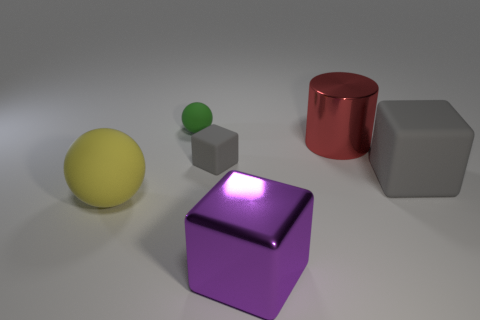Add 4 big red metallic objects. How many objects exist? 10 Subtract all balls. How many objects are left? 4 Add 2 large purple metal things. How many large purple metal things are left? 3 Add 4 large red cylinders. How many large red cylinders exist? 5 Subtract 0 gray balls. How many objects are left? 6 Subtract all large shiny cubes. Subtract all yellow objects. How many objects are left? 4 